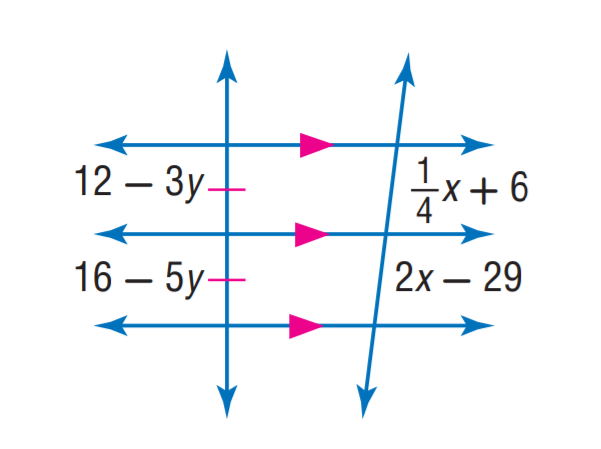Answer the mathemtical geometry problem and directly provide the correct option letter.
Question: Find x.
Choices: A: 12 B: 16 C: 20 D: 29 C 